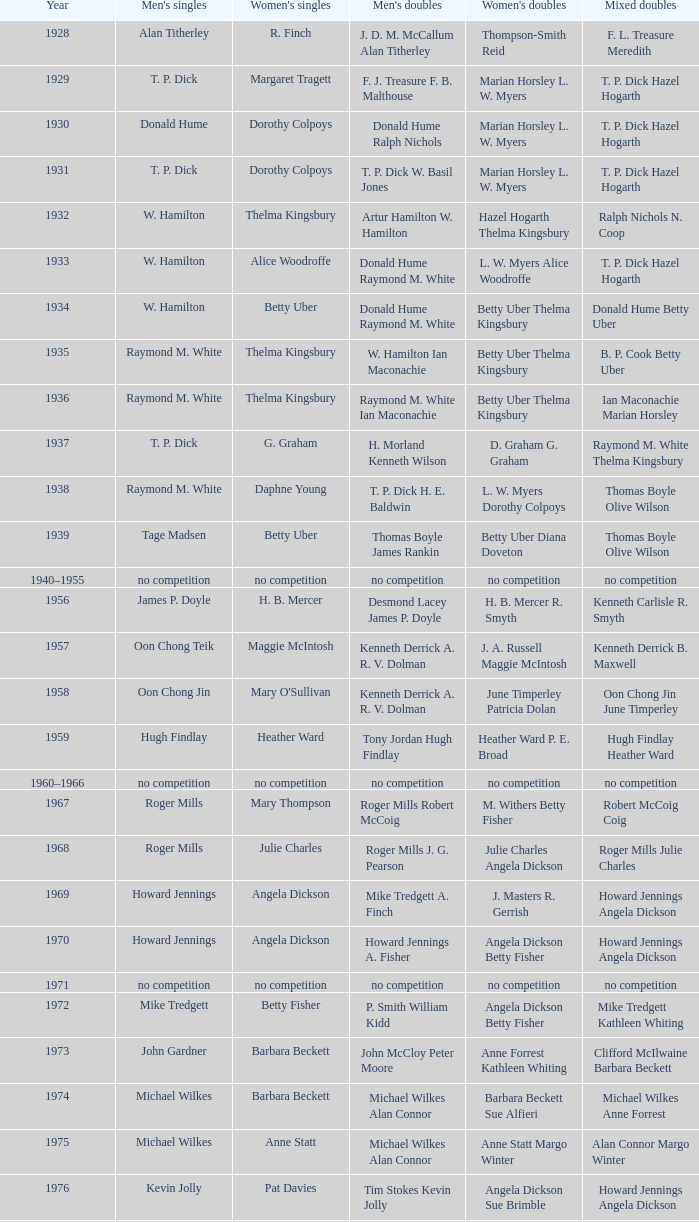In the year when david eddy eddy sutton clinched the men's doubles title and david eddy secured the men's singles championship, who were the victors in the women's doubles event? Anne Statt Jane Webster. 